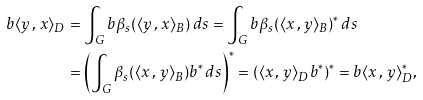Convert formula to latex. <formula><loc_0><loc_0><loc_500><loc_500>b \langle y \, , \, x \rangle _ { D } & = \int _ { G } b \beta _ { s } ( \langle y \, , \, x \rangle _ { B } ) \, d s = \int _ { G } b \beta _ { s } ( \langle x \, , \, y \rangle _ { B } ) ^ { * } \, d s \\ & = \left ( \int _ { G } \beta _ { s } ( \langle x \, , \, y \rangle _ { B } ) b ^ { * } \, d s \right ) ^ { * } = ( \langle x \, , \, y \rangle _ { D } b ^ { * } ) ^ { * } = b \langle x \, , \, y \rangle _ { D } ^ { * } ,</formula> 